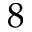<formula> <loc_0><loc_0><loc_500><loc_500>8</formula> 